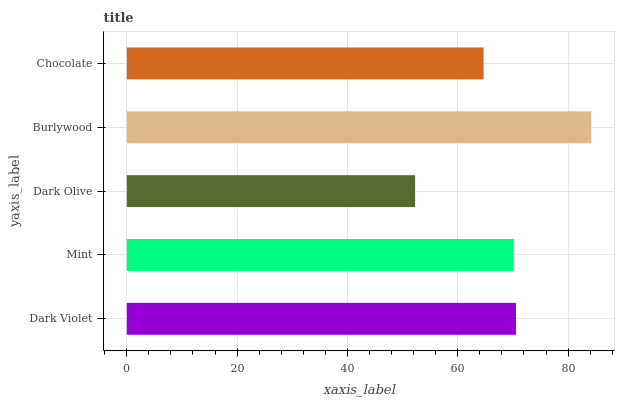Is Dark Olive the minimum?
Answer yes or no. Yes. Is Burlywood the maximum?
Answer yes or no. Yes. Is Mint the minimum?
Answer yes or no. No. Is Mint the maximum?
Answer yes or no. No. Is Dark Violet greater than Mint?
Answer yes or no. Yes. Is Mint less than Dark Violet?
Answer yes or no. Yes. Is Mint greater than Dark Violet?
Answer yes or no. No. Is Dark Violet less than Mint?
Answer yes or no. No. Is Mint the high median?
Answer yes or no. Yes. Is Mint the low median?
Answer yes or no. Yes. Is Burlywood the high median?
Answer yes or no. No. Is Dark Olive the low median?
Answer yes or no. No. 